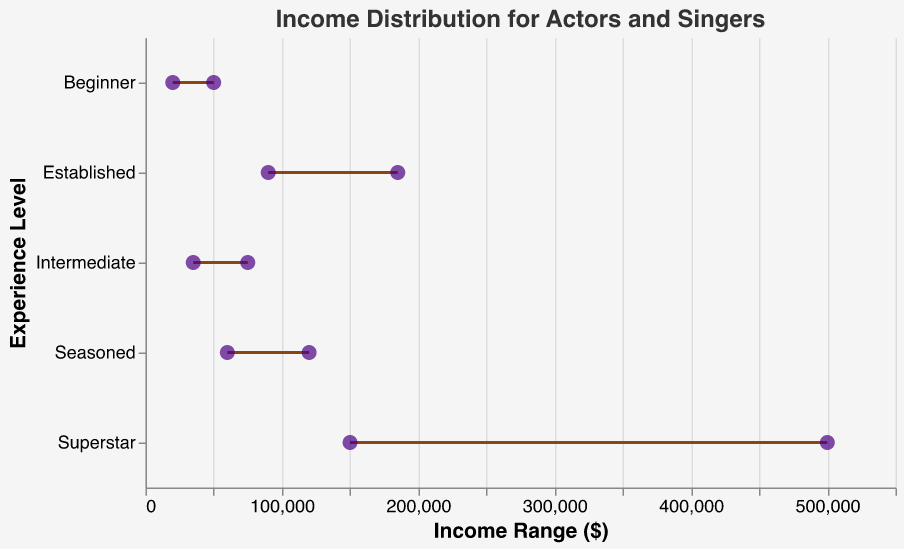What's the title of the plot? The title is usually found at the top of the plot and is styled to stand out. The figure title is "Income Distribution for Actors and Singers."
Answer: Income Distribution for Actors and Singers What does the x-axis represent? The x-axis title usually denotes what values are being plotted horizontally. The figure clearly labels the x-axis as "Income Range ($)."
Answer: Income Range ($) Which experience level has the highest possible income? The plot shows income ranges connected by lines. For the highest possible income, look for the endpoint of the longest line on the x-axis. "Superstar" shows the maximum income of $500,000.
Answer: Superstar What's the income range for an Intermediate experience level? The plot has lines representing income ranges for each experience level. For Intermediate, the line spans from $35,000 to $75,000 on the x-axis.
Answer: $35,000 to $75,000 How much more is the maximum income of an Established professional compared to a Beginner? Compare the maximum endpoints of the lines representing Established and Beginner. Established goes up to $185,000, and Beginner goes up to $50,000. The difference is $185,000 - $50,000 = $135,000.
Answer: $135,000 Which experience level shows the least variation in income? Variation in income can be gauged by the length of the line for each experience level. The shortest line represents the smallest variation. "Intermediate" has the shortest line spanning $35,000 to $75,000.
Answer: Intermediate How does the income range for Beginners compare to Seasoned professionals? Compare the beginning and ending points of the lines for both levels. Beginners range from $20,000 to $50,000, while Seasoned ranges from $60,000 to $120,000. Seasoned professionals have a higher range overall.
Answer: Seasoned professionals have a higher range By how much does the minimum income of Superstars exceed that of Established professionals? Locate the beginning points of the lines for Superstars and Established. Superstars start at $150,000 and Established at $90,000. The difference is $150,000 - $90,000 = $60,000.
Answer: $60,000 What's the average income range for the Seasoned experience level? To find the average, add the min and max of the income range and divide by 2. For Seasoned, it's ($60,000 + $120,000) / 2 = $90,000.
Answer: $90,000 Which experience level has the closest minimum income to $40,000? Find the lines' starting points nearest to $40,000. The closest to $40,000 is Intermediate, which starts at $35,000.
Answer: Intermediate 